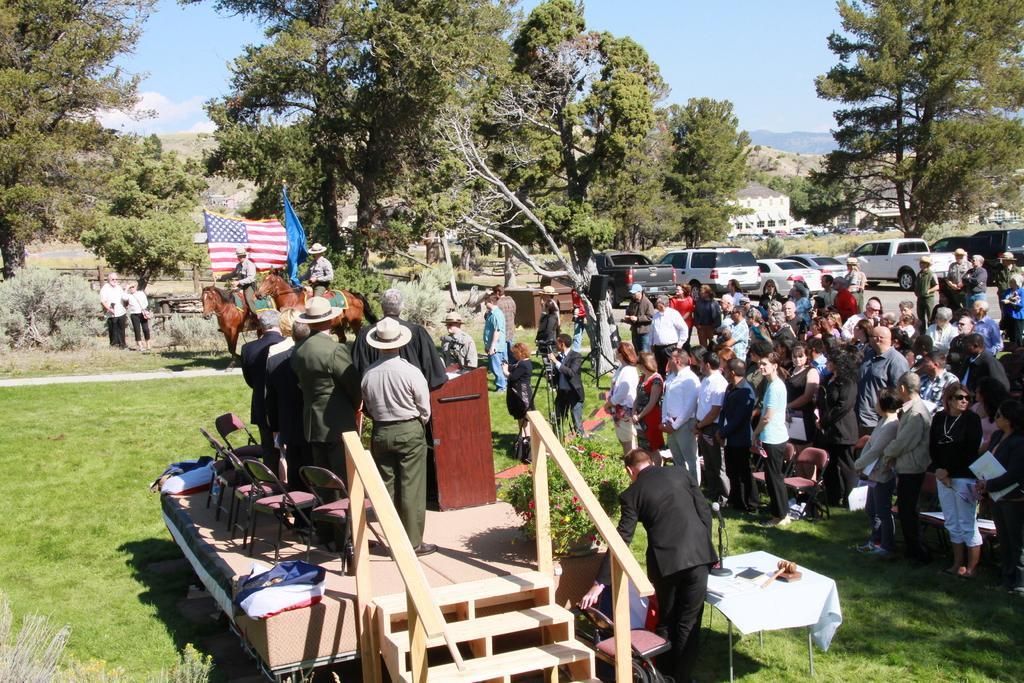Can you describe this image briefly? This is an outside view. On the right side a crowd of people standing on the ground. On the left side there is a stage on which few people are standing and there are some chairs and a podium. At the bottom, I can see the stairs. In the background two people are holding the flags in the hands and sitting on the horses. These people are looking at these people. In the background there are many vehicles on the road and also I can see the trees. At the top of the image I can see the sky. 